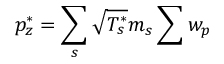<formula> <loc_0><loc_0><loc_500><loc_500>p _ { z } ^ { * } = \sum _ { s } \sqrt { T _ { s } ^ { * } } m _ { s } \sum w _ { p }</formula> 